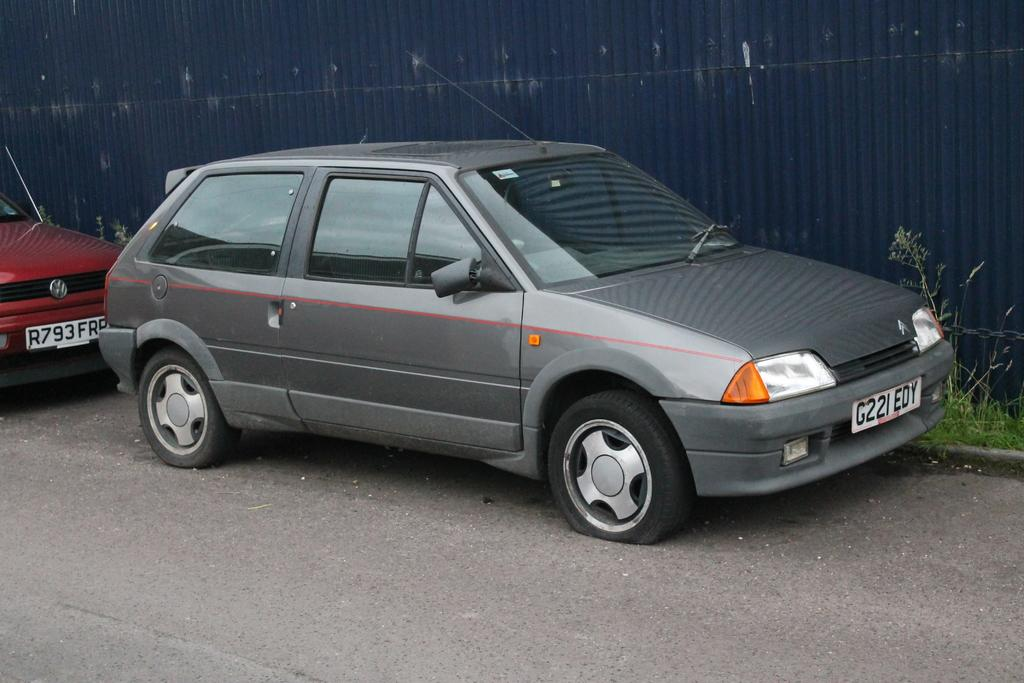What color is the vehicle parked on the road? The vehicle parked on the road is gray in color. Can you describe the other vehicle in the image? There is a red color vehicle near the gray vehicle. What type of surface is visible on the ground? There is grass on the ground. What color is the wall near the grass? The wall near the grass is violet in color. How many pages are visible in the image? There are no pages present in the image; it features vehicles, grass, and a wall. What type of clouds can be seen in the image? There are no clouds visible in the image. 